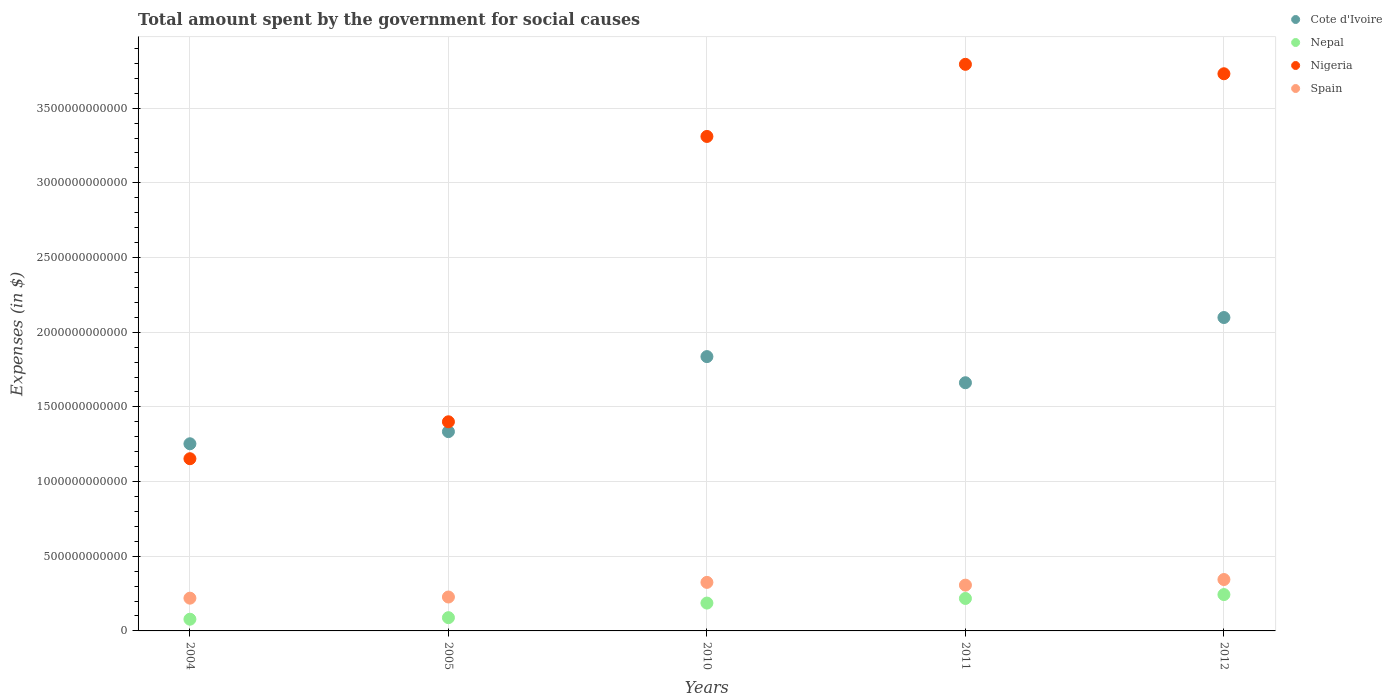What is the amount spent for social causes by the government in Nigeria in 2010?
Offer a terse response. 3.31e+12. Across all years, what is the maximum amount spent for social causes by the government in Cote d'Ivoire?
Offer a terse response. 2.10e+12. Across all years, what is the minimum amount spent for social causes by the government in Nepal?
Offer a very short reply. 7.83e+1. In which year was the amount spent for social causes by the government in Cote d'Ivoire minimum?
Provide a succinct answer. 2004. What is the total amount spent for social causes by the government in Nigeria in the graph?
Your answer should be compact. 1.34e+13. What is the difference between the amount spent for social causes by the government in Spain in 2004 and that in 2011?
Your answer should be compact. -8.73e+1. What is the difference between the amount spent for social causes by the government in Nepal in 2011 and the amount spent for social causes by the government in Nigeria in 2010?
Keep it short and to the point. -3.09e+12. What is the average amount spent for social causes by the government in Spain per year?
Offer a terse response. 2.84e+11. In the year 2004, what is the difference between the amount spent for social causes by the government in Cote d'Ivoire and amount spent for social causes by the government in Nepal?
Give a very brief answer. 1.17e+12. What is the ratio of the amount spent for social causes by the government in Spain in 2010 to that in 2011?
Offer a very short reply. 1.06. What is the difference between the highest and the second highest amount spent for social causes by the government in Nepal?
Make the answer very short. 2.60e+1. What is the difference between the highest and the lowest amount spent for social causes by the government in Nigeria?
Offer a very short reply. 2.64e+12. In how many years, is the amount spent for social causes by the government in Nepal greater than the average amount spent for social causes by the government in Nepal taken over all years?
Offer a terse response. 3. Is the sum of the amount spent for social causes by the government in Nigeria in 2010 and 2011 greater than the maximum amount spent for social causes by the government in Spain across all years?
Keep it short and to the point. Yes. Is the amount spent for social causes by the government in Nepal strictly greater than the amount spent for social causes by the government in Nigeria over the years?
Your answer should be very brief. No. What is the difference between two consecutive major ticks on the Y-axis?
Give a very brief answer. 5.00e+11. Where does the legend appear in the graph?
Offer a terse response. Top right. What is the title of the graph?
Keep it short and to the point. Total amount spent by the government for social causes. Does "St. Vincent and the Grenadines" appear as one of the legend labels in the graph?
Provide a short and direct response. No. What is the label or title of the X-axis?
Give a very brief answer. Years. What is the label or title of the Y-axis?
Your answer should be compact. Expenses (in $). What is the Expenses (in $) in Cote d'Ivoire in 2004?
Offer a very short reply. 1.25e+12. What is the Expenses (in $) of Nepal in 2004?
Your answer should be compact. 7.83e+1. What is the Expenses (in $) in Nigeria in 2004?
Offer a terse response. 1.15e+12. What is the Expenses (in $) of Spain in 2004?
Your answer should be compact. 2.19e+11. What is the Expenses (in $) of Cote d'Ivoire in 2005?
Your answer should be very brief. 1.33e+12. What is the Expenses (in $) in Nepal in 2005?
Make the answer very short. 8.88e+1. What is the Expenses (in $) in Nigeria in 2005?
Ensure brevity in your answer.  1.40e+12. What is the Expenses (in $) in Spain in 2005?
Ensure brevity in your answer.  2.27e+11. What is the Expenses (in $) in Cote d'Ivoire in 2010?
Ensure brevity in your answer.  1.84e+12. What is the Expenses (in $) of Nepal in 2010?
Your response must be concise. 1.86e+11. What is the Expenses (in $) in Nigeria in 2010?
Offer a very short reply. 3.31e+12. What is the Expenses (in $) of Spain in 2010?
Ensure brevity in your answer.  3.25e+11. What is the Expenses (in $) of Cote d'Ivoire in 2011?
Provide a succinct answer. 1.66e+12. What is the Expenses (in $) of Nepal in 2011?
Your answer should be compact. 2.17e+11. What is the Expenses (in $) of Nigeria in 2011?
Provide a short and direct response. 3.79e+12. What is the Expenses (in $) of Spain in 2011?
Offer a very short reply. 3.07e+11. What is the Expenses (in $) in Cote d'Ivoire in 2012?
Ensure brevity in your answer.  2.10e+12. What is the Expenses (in $) in Nepal in 2012?
Give a very brief answer. 2.43e+11. What is the Expenses (in $) of Nigeria in 2012?
Give a very brief answer. 3.73e+12. What is the Expenses (in $) of Spain in 2012?
Offer a very short reply. 3.44e+11. Across all years, what is the maximum Expenses (in $) of Cote d'Ivoire?
Give a very brief answer. 2.10e+12. Across all years, what is the maximum Expenses (in $) in Nepal?
Provide a succinct answer. 2.43e+11. Across all years, what is the maximum Expenses (in $) in Nigeria?
Your answer should be compact. 3.79e+12. Across all years, what is the maximum Expenses (in $) in Spain?
Provide a short and direct response. 3.44e+11. Across all years, what is the minimum Expenses (in $) in Cote d'Ivoire?
Provide a short and direct response. 1.25e+12. Across all years, what is the minimum Expenses (in $) in Nepal?
Ensure brevity in your answer.  7.83e+1. Across all years, what is the minimum Expenses (in $) of Nigeria?
Offer a very short reply. 1.15e+12. Across all years, what is the minimum Expenses (in $) in Spain?
Keep it short and to the point. 2.19e+11. What is the total Expenses (in $) of Cote d'Ivoire in the graph?
Offer a terse response. 8.18e+12. What is the total Expenses (in $) of Nepal in the graph?
Offer a very short reply. 8.14e+11. What is the total Expenses (in $) of Nigeria in the graph?
Provide a succinct answer. 1.34e+13. What is the total Expenses (in $) of Spain in the graph?
Provide a short and direct response. 1.42e+12. What is the difference between the Expenses (in $) of Cote d'Ivoire in 2004 and that in 2005?
Your answer should be compact. -8.12e+1. What is the difference between the Expenses (in $) of Nepal in 2004 and that in 2005?
Make the answer very short. -1.04e+1. What is the difference between the Expenses (in $) of Nigeria in 2004 and that in 2005?
Your answer should be compact. -2.47e+11. What is the difference between the Expenses (in $) in Spain in 2004 and that in 2005?
Provide a succinct answer. -7.71e+09. What is the difference between the Expenses (in $) of Cote d'Ivoire in 2004 and that in 2010?
Your answer should be compact. -5.84e+11. What is the difference between the Expenses (in $) of Nepal in 2004 and that in 2010?
Provide a short and direct response. -1.08e+11. What is the difference between the Expenses (in $) of Nigeria in 2004 and that in 2010?
Your answer should be compact. -2.16e+12. What is the difference between the Expenses (in $) in Spain in 2004 and that in 2010?
Make the answer very short. -1.06e+11. What is the difference between the Expenses (in $) of Cote d'Ivoire in 2004 and that in 2011?
Your response must be concise. -4.09e+11. What is the difference between the Expenses (in $) of Nepal in 2004 and that in 2011?
Provide a short and direct response. -1.39e+11. What is the difference between the Expenses (in $) in Nigeria in 2004 and that in 2011?
Provide a succinct answer. -2.64e+12. What is the difference between the Expenses (in $) of Spain in 2004 and that in 2011?
Offer a terse response. -8.73e+1. What is the difference between the Expenses (in $) of Cote d'Ivoire in 2004 and that in 2012?
Give a very brief answer. -8.45e+11. What is the difference between the Expenses (in $) in Nepal in 2004 and that in 2012?
Give a very brief answer. -1.65e+11. What is the difference between the Expenses (in $) of Nigeria in 2004 and that in 2012?
Offer a very short reply. -2.58e+12. What is the difference between the Expenses (in $) in Spain in 2004 and that in 2012?
Offer a terse response. -1.25e+11. What is the difference between the Expenses (in $) of Cote d'Ivoire in 2005 and that in 2010?
Your response must be concise. -5.02e+11. What is the difference between the Expenses (in $) of Nepal in 2005 and that in 2010?
Provide a succinct answer. -9.77e+1. What is the difference between the Expenses (in $) in Nigeria in 2005 and that in 2010?
Your answer should be very brief. -1.91e+12. What is the difference between the Expenses (in $) in Spain in 2005 and that in 2010?
Your answer should be very brief. -9.80e+1. What is the difference between the Expenses (in $) in Cote d'Ivoire in 2005 and that in 2011?
Give a very brief answer. -3.27e+11. What is the difference between the Expenses (in $) in Nepal in 2005 and that in 2011?
Your response must be concise. -1.29e+11. What is the difference between the Expenses (in $) of Nigeria in 2005 and that in 2011?
Provide a succinct answer. -2.39e+12. What is the difference between the Expenses (in $) of Spain in 2005 and that in 2011?
Give a very brief answer. -7.96e+1. What is the difference between the Expenses (in $) of Cote d'Ivoire in 2005 and that in 2012?
Make the answer very short. -7.64e+11. What is the difference between the Expenses (in $) in Nepal in 2005 and that in 2012?
Offer a very short reply. -1.55e+11. What is the difference between the Expenses (in $) of Nigeria in 2005 and that in 2012?
Give a very brief answer. -2.33e+12. What is the difference between the Expenses (in $) in Spain in 2005 and that in 2012?
Your response must be concise. -1.17e+11. What is the difference between the Expenses (in $) of Cote d'Ivoire in 2010 and that in 2011?
Ensure brevity in your answer.  1.75e+11. What is the difference between the Expenses (in $) in Nepal in 2010 and that in 2011?
Your response must be concise. -3.08e+1. What is the difference between the Expenses (in $) of Nigeria in 2010 and that in 2011?
Provide a short and direct response. -4.83e+11. What is the difference between the Expenses (in $) in Spain in 2010 and that in 2011?
Provide a short and direct response. 1.84e+1. What is the difference between the Expenses (in $) in Cote d'Ivoire in 2010 and that in 2012?
Keep it short and to the point. -2.62e+11. What is the difference between the Expenses (in $) of Nepal in 2010 and that in 2012?
Give a very brief answer. -5.69e+1. What is the difference between the Expenses (in $) in Nigeria in 2010 and that in 2012?
Your answer should be compact. -4.20e+11. What is the difference between the Expenses (in $) in Spain in 2010 and that in 2012?
Keep it short and to the point. -1.91e+1. What is the difference between the Expenses (in $) of Cote d'Ivoire in 2011 and that in 2012?
Your answer should be very brief. -4.37e+11. What is the difference between the Expenses (in $) in Nepal in 2011 and that in 2012?
Your response must be concise. -2.60e+1. What is the difference between the Expenses (in $) of Nigeria in 2011 and that in 2012?
Keep it short and to the point. 6.32e+1. What is the difference between the Expenses (in $) of Spain in 2011 and that in 2012?
Keep it short and to the point. -3.75e+1. What is the difference between the Expenses (in $) in Cote d'Ivoire in 2004 and the Expenses (in $) in Nepal in 2005?
Your answer should be very brief. 1.16e+12. What is the difference between the Expenses (in $) in Cote d'Ivoire in 2004 and the Expenses (in $) in Nigeria in 2005?
Make the answer very short. -1.47e+11. What is the difference between the Expenses (in $) of Cote d'Ivoire in 2004 and the Expenses (in $) of Spain in 2005?
Your response must be concise. 1.03e+12. What is the difference between the Expenses (in $) of Nepal in 2004 and the Expenses (in $) of Nigeria in 2005?
Ensure brevity in your answer.  -1.32e+12. What is the difference between the Expenses (in $) of Nepal in 2004 and the Expenses (in $) of Spain in 2005?
Provide a succinct answer. -1.49e+11. What is the difference between the Expenses (in $) of Nigeria in 2004 and the Expenses (in $) of Spain in 2005?
Your answer should be very brief. 9.26e+11. What is the difference between the Expenses (in $) in Cote d'Ivoire in 2004 and the Expenses (in $) in Nepal in 2010?
Your response must be concise. 1.07e+12. What is the difference between the Expenses (in $) of Cote d'Ivoire in 2004 and the Expenses (in $) of Nigeria in 2010?
Offer a very short reply. -2.06e+12. What is the difference between the Expenses (in $) of Cote d'Ivoire in 2004 and the Expenses (in $) of Spain in 2010?
Provide a short and direct response. 9.28e+11. What is the difference between the Expenses (in $) of Nepal in 2004 and the Expenses (in $) of Nigeria in 2010?
Your response must be concise. -3.23e+12. What is the difference between the Expenses (in $) in Nepal in 2004 and the Expenses (in $) in Spain in 2010?
Ensure brevity in your answer.  -2.47e+11. What is the difference between the Expenses (in $) in Nigeria in 2004 and the Expenses (in $) in Spain in 2010?
Give a very brief answer. 8.28e+11. What is the difference between the Expenses (in $) in Cote d'Ivoire in 2004 and the Expenses (in $) in Nepal in 2011?
Your answer should be very brief. 1.04e+12. What is the difference between the Expenses (in $) in Cote d'Ivoire in 2004 and the Expenses (in $) in Nigeria in 2011?
Your answer should be compact. -2.54e+12. What is the difference between the Expenses (in $) of Cote d'Ivoire in 2004 and the Expenses (in $) of Spain in 2011?
Your answer should be compact. 9.47e+11. What is the difference between the Expenses (in $) of Nepal in 2004 and the Expenses (in $) of Nigeria in 2011?
Make the answer very short. -3.72e+12. What is the difference between the Expenses (in $) in Nepal in 2004 and the Expenses (in $) in Spain in 2011?
Your response must be concise. -2.28e+11. What is the difference between the Expenses (in $) of Nigeria in 2004 and the Expenses (in $) of Spain in 2011?
Offer a terse response. 8.46e+11. What is the difference between the Expenses (in $) of Cote d'Ivoire in 2004 and the Expenses (in $) of Nepal in 2012?
Offer a terse response. 1.01e+12. What is the difference between the Expenses (in $) of Cote d'Ivoire in 2004 and the Expenses (in $) of Nigeria in 2012?
Your answer should be very brief. -2.48e+12. What is the difference between the Expenses (in $) of Cote d'Ivoire in 2004 and the Expenses (in $) of Spain in 2012?
Give a very brief answer. 9.09e+11. What is the difference between the Expenses (in $) of Nepal in 2004 and the Expenses (in $) of Nigeria in 2012?
Make the answer very short. -3.65e+12. What is the difference between the Expenses (in $) of Nepal in 2004 and the Expenses (in $) of Spain in 2012?
Offer a very short reply. -2.66e+11. What is the difference between the Expenses (in $) in Nigeria in 2004 and the Expenses (in $) in Spain in 2012?
Make the answer very short. 8.09e+11. What is the difference between the Expenses (in $) of Cote d'Ivoire in 2005 and the Expenses (in $) of Nepal in 2010?
Make the answer very short. 1.15e+12. What is the difference between the Expenses (in $) in Cote d'Ivoire in 2005 and the Expenses (in $) in Nigeria in 2010?
Make the answer very short. -1.98e+12. What is the difference between the Expenses (in $) in Cote d'Ivoire in 2005 and the Expenses (in $) in Spain in 2010?
Provide a short and direct response. 1.01e+12. What is the difference between the Expenses (in $) of Nepal in 2005 and the Expenses (in $) of Nigeria in 2010?
Offer a terse response. -3.22e+12. What is the difference between the Expenses (in $) of Nepal in 2005 and the Expenses (in $) of Spain in 2010?
Provide a succinct answer. -2.36e+11. What is the difference between the Expenses (in $) of Nigeria in 2005 and the Expenses (in $) of Spain in 2010?
Make the answer very short. 1.08e+12. What is the difference between the Expenses (in $) of Cote d'Ivoire in 2005 and the Expenses (in $) of Nepal in 2011?
Your answer should be very brief. 1.12e+12. What is the difference between the Expenses (in $) of Cote d'Ivoire in 2005 and the Expenses (in $) of Nigeria in 2011?
Give a very brief answer. -2.46e+12. What is the difference between the Expenses (in $) in Cote d'Ivoire in 2005 and the Expenses (in $) in Spain in 2011?
Your response must be concise. 1.03e+12. What is the difference between the Expenses (in $) in Nepal in 2005 and the Expenses (in $) in Nigeria in 2011?
Make the answer very short. -3.70e+12. What is the difference between the Expenses (in $) in Nepal in 2005 and the Expenses (in $) in Spain in 2011?
Provide a short and direct response. -2.18e+11. What is the difference between the Expenses (in $) of Nigeria in 2005 and the Expenses (in $) of Spain in 2011?
Keep it short and to the point. 1.09e+12. What is the difference between the Expenses (in $) in Cote d'Ivoire in 2005 and the Expenses (in $) in Nepal in 2012?
Offer a very short reply. 1.09e+12. What is the difference between the Expenses (in $) of Cote d'Ivoire in 2005 and the Expenses (in $) of Nigeria in 2012?
Give a very brief answer. -2.40e+12. What is the difference between the Expenses (in $) of Cote d'Ivoire in 2005 and the Expenses (in $) of Spain in 2012?
Give a very brief answer. 9.90e+11. What is the difference between the Expenses (in $) of Nepal in 2005 and the Expenses (in $) of Nigeria in 2012?
Offer a terse response. -3.64e+12. What is the difference between the Expenses (in $) in Nepal in 2005 and the Expenses (in $) in Spain in 2012?
Make the answer very short. -2.55e+11. What is the difference between the Expenses (in $) in Nigeria in 2005 and the Expenses (in $) in Spain in 2012?
Provide a succinct answer. 1.06e+12. What is the difference between the Expenses (in $) of Cote d'Ivoire in 2010 and the Expenses (in $) of Nepal in 2011?
Give a very brief answer. 1.62e+12. What is the difference between the Expenses (in $) of Cote d'Ivoire in 2010 and the Expenses (in $) of Nigeria in 2011?
Give a very brief answer. -1.96e+12. What is the difference between the Expenses (in $) of Cote d'Ivoire in 2010 and the Expenses (in $) of Spain in 2011?
Give a very brief answer. 1.53e+12. What is the difference between the Expenses (in $) in Nepal in 2010 and the Expenses (in $) in Nigeria in 2011?
Offer a very short reply. -3.61e+12. What is the difference between the Expenses (in $) in Nepal in 2010 and the Expenses (in $) in Spain in 2011?
Ensure brevity in your answer.  -1.20e+11. What is the difference between the Expenses (in $) of Nigeria in 2010 and the Expenses (in $) of Spain in 2011?
Your answer should be very brief. 3.00e+12. What is the difference between the Expenses (in $) of Cote d'Ivoire in 2010 and the Expenses (in $) of Nepal in 2012?
Make the answer very short. 1.59e+12. What is the difference between the Expenses (in $) of Cote d'Ivoire in 2010 and the Expenses (in $) of Nigeria in 2012?
Ensure brevity in your answer.  -1.89e+12. What is the difference between the Expenses (in $) of Cote d'Ivoire in 2010 and the Expenses (in $) of Spain in 2012?
Your answer should be compact. 1.49e+12. What is the difference between the Expenses (in $) in Nepal in 2010 and the Expenses (in $) in Nigeria in 2012?
Offer a terse response. -3.54e+12. What is the difference between the Expenses (in $) of Nepal in 2010 and the Expenses (in $) of Spain in 2012?
Provide a short and direct response. -1.58e+11. What is the difference between the Expenses (in $) in Nigeria in 2010 and the Expenses (in $) in Spain in 2012?
Give a very brief answer. 2.97e+12. What is the difference between the Expenses (in $) in Cote d'Ivoire in 2011 and the Expenses (in $) in Nepal in 2012?
Provide a succinct answer. 1.42e+12. What is the difference between the Expenses (in $) of Cote d'Ivoire in 2011 and the Expenses (in $) of Nigeria in 2012?
Keep it short and to the point. -2.07e+12. What is the difference between the Expenses (in $) in Cote d'Ivoire in 2011 and the Expenses (in $) in Spain in 2012?
Keep it short and to the point. 1.32e+12. What is the difference between the Expenses (in $) of Nepal in 2011 and the Expenses (in $) of Nigeria in 2012?
Your response must be concise. -3.51e+12. What is the difference between the Expenses (in $) of Nepal in 2011 and the Expenses (in $) of Spain in 2012?
Offer a very short reply. -1.27e+11. What is the difference between the Expenses (in $) in Nigeria in 2011 and the Expenses (in $) in Spain in 2012?
Your answer should be compact. 3.45e+12. What is the average Expenses (in $) in Cote d'Ivoire per year?
Your answer should be compact. 1.64e+12. What is the average Expenses (in $) of Nepal per year?
Give a very brief answer. 1.63e+11. What is the average Expenses (in $) of Nigeria per year?
Offer a terse response. 2.68e+12. What is the average Expenses (in $) of Spain per year?
Make the answer very short. 2.84e+11. In the year 2004, what is the difference between the Expenses (in $) of Cote d'Ivoire and Expenses (in $) of Nepal?
Offer a very short reply. 1.17e+12. In the year 2004, what is the difference between the Expenses (in $) of Cote d'Ivoire and Expenses (in $) of Nigeria?
Ensure brevity in your answer.  1.00e+11. In the year 2004, what is the difference between the Expenses (in $) in Cote d'Ivoire and Expenses (in $) in Spain?
Offer a terse response. 1.03e+12. In the year 2004, what is the difference between the Expenses (in $) in Nepal and Expenses (in $) in Nigeria?
Ensure brevity in your answer.  -1.07e+12. In the year 2004, what is the difference between the Expenses (in $) of Nepal and Expenses (in $) of Spain?
Your answer should be very brief. -1.41e+11. In the year 2004, what is the difference between the Expenses (in $) of Nigeria and Expenses (in $) of Spain?
Your answer should be very brief. 9.34e+11. In the year 2005, what is the difference between the Expenses (in $) in Cote d'Ivoire and Expenses (in $) in Nepal?
Your answer should be very brief. 1.25e+12. In the year 2005, what is the difference between the Expenses (in $) of Cote d'Ivoire and Expenses (in $) of Nigeria?
Ensure brevity in your answer.  -6.60e+1. In the year 2005, what is the difference between the Expenses (in $) of Cote d'Ivoire and Expenses (in $) of Spain?
Ensure brevity in your answer.  1.11e+12. In the year 2005, what is the difference between the Expenses (in $) of Nepal and Expenses (in $) of Nigeria?
Provide a succinct answer. -1.31e+12. In the year 2005, what is the difference between the Expenses (in $) in Nepal and Expenses (in $) in Spain?
Provide a short and direct response. -1.38e+11. In the year 2005, what is the difference between the Expenses (in $) in Nigeria and Expenses (in $) in Spain?
Your answer should be compact. 1.17e+12. In the year 2010, what is the difference between the Expenses (in $) of Cote d'Ivoire and Expenses (in $) of Nepal?
Make the answer very short. 1.65e+12. In the year 2010, what is the difference between the Expenses (in $) in Cote d'Ivoire and Expenses (in $) in Nigeria?
Give a very brief answer. -1.47e+12. In the year 2010, what is the difference between the Expenses (in $) in Cote d'Ivoire and Expenses (in $) in Spain?
Make the answer very short. 1.51e+12. In the year 2010, what is the difference between the Expenses (in $) in Nepal and Expenses (in $) in Nigeria?
Ensure brevity in your answer.  -3.12e+12. In the year 2010, what is the difference between the Expenses (in $) of Nepal and Expenses (in $) of Spain?
Give a very brief answer. -1.39e+11. In the year 2010, what is the difference between the Expenses (in $) in Nigeria and Expenses (in $) in Spain?
Offer a very short reply. 2.99e+12. In the year 2011, what is the difference between the Expenses (in $) in Cote d'Ivoire and Expenses (in $) in Nepal?
Provide a short and direct response. 1.44e+12. In the year 2011, what is the difference between the Expenses (in $) in Cote d'Ivoire and Expenses (in $) in Nigeria?
Keep it short and to the point. -2.13e+12. In the year 2011, what is the difference between the Expenses (in $) of Cote d'Ivoire and Expenses (in $) of Spain?
Offer a terse response. 1.36e+12. In the year 2011, what is the difference between the Expenses (in $) in Nepal and Expenses (in $) in Nigeria?
Offer a very short reply. -3.58e+12. In the year 2011, what is the difference between the Expenses (in $) in Nepal and Expenses (in $) in Spain?
Ensure brevity in your answer.  -8.93e+1. In the year 2011, what is the difference between the Expenses (in $) in Nigeria and Expenses (in $) in Spain?
Offer a very short reply. 3.49e+12. In the year 2012, what is the difference between the Expenses (in $) of Cote d'Ivoire and Expenses (in $) of Nepal?
Offer a terse response. 1.86e+12. In the year 2012, what is the difference between the Expenses (in $) of Cote d'Ivoire and Expenses (in $) of Nigeria?
Your answer should be compact. -1.63e+12. In the year 2012, what is the difference between the Expenses (in $) of Cote d'Ivoire and Expenses (in $) of Spain?
Make the answer very short. 1.75e+12. In the year 2012, what is the difference between the Expenses (in $) of Nepal and Expenses (in $) of Nigeria?
Your answer should be very brief. -3.49e+12. In the year 2012, what is the difference between the Expenses (in $) of Nepal and Expenses (in $) of Spain?
Your answer should be very brief. -1.01e+11. In the year 2012, what is the difference between the Expenses (in $) in Nigeria and Expenses (in $) in Spain?
Offer a very short reply. 3.39e+12. What is the ratio of the Expenses (in $) in Cote d'Ivoire in 2004 to that in 2005?
Provide a succinct answer. 0.94. What is the ratio of the Expenses (in $) of Nepal in 2004 to that in 2005?
Your answer should be compact. 0.88. What is the ratio of the Expenses (in $) in Nigeria in 2004 to that in 2005?
Your answer should be compact. 0.82. What is the ratio of the Expenses (in $) in Spain in 2004 to that in 2005?
Keep it short and to the point. 0.97. What is the ratio of the Expenses (in $) of Cote d'Ivoire in 2004 to that in 2010?
Your answer should be compact. 0.68. What is the ratio of the Expenses (in $) in Nepal in 2004 to that in 2010?
Keep it short and to the point. 0.42. What is the ratio of the Expenses (in $) of Nigeria in 2004 to that in 2010?
Offer a terse response. 0.35. What is the ratio of the Expenses (in $) in Spain in 2004 to that in 2010?
Your response must be concise. 0.67. What is the ratio of the Expenses (in $) of Cote d'Ivoire in 2004 to that in 2011?
Your response must be concise. 0.75. What is the ratio of the Expenses (in $) in Nepal in 2004 to that in 2011?
Keep it short and to the point. 0.36. What is the ratio of the Expenses (in $) in Nigeria in 2004 to that in 2011?
Give a very brief answer. 0.3. What is the ratio of the Expenses (in $) in Spain in 2004 to that in 2011?
Keep it short and to the point. 0.72. What is the ratio of the Expenses (in $) in Cote d'Ivoire in 2004 to that in 2012?
Your answer should be very brief. 0.6. What is the ratio of the Expenses (in $) in Nepal in 2004 to that in 2012?
Your answer should be very brief. 0.32. What is the ratio of the Expenses (in $) of Nigeria in 2004 to that in 2012?
Provide a succinct answer. 0.31. What is the ratio of the Expenses (in $) of Spain in 2004 to that in 2012?
Provide a succinct answer. 0.64. What is the ratio of the Expenses (in $) in Cote d'Ivoire in 2005 to that in 2010?
Give a very brief answer. 0.73. What is the ratio of the Expenses (in $) of Nepal in 2005 to that in 2010?
Provide a succinct answer. 0.48. What is the ratio of the Expenses (in $) of Nigeria in 2005 to that in 2010?
Give a very brief answer. 0.42. What is the ratio of the Expenses (in $) in Spain in 2005 to that in 2010?
Offer a terse response. 0.7. What is the ratio of the Expenses (in $) of Cote d'Ivoire in 2005 to that in 2011?
Offer a very short reply. 0.8. What is the ratio of the Expenses (in $) in Nepal in 2005 to that in 2011?
Your response must be concise. 0.41. What is the ratio of the Expenses (in $) of Nigeria in 2005 to that in 2011?
Offer a very short reply. 0.37. What is the ratio of the Expenses (in $) in Spain in 2005 to that in 2011?
Your response must be concise. 0.74. What is the ratio of the Expenses (in $) in Cote d'Ivoire in 2005 to that in 2012?
Offer a terse response. 0.64. What is the ratio of the Expenses (in $) of Nepal in 2005 to that in 2012?
Offer a terse response. 0.36. What is the ratio of the Expenses (in $) of Nigeria in 2005 to that in 2012?
Keep it short and to the point. 0.38. What is the ratio of the Expenses (in $) in Spain in 2005 to that in 2012?
Give a very brief answer. 0.66. What is the ratio of the Expenses (in $) of Cote d'Ivoire in 2010 to that in 2011?
Provide a short and direct response. 1.11. What is the ratio of the Expenses (in $) in Nepal in 2010 to that in 2011?
Make the answer very short. 0.86. What is the ratio of the Expenses (in $) of Nigeria in 2010 to that in 2011?
Ensure brevity in your answer.  0.87. What is the ratio of the Expenses (in $) in Spain in 2010 to that in 2011?
Make the answer very short. 1.06. What is the ratio of the Expenses (in $) in Cote d'Ivoire in 2010 to that in 2012?
Ensure brevity in your answer.  0.88. What is the ratio of the Expenses (in $) of Nepal in 2010 to that in 2012?
Make the answer very short. 0.77. What is the ratio of the Expenses (in $) of Nigeria in 2010 to that in 2012?
Keep it short and to the point. 0.89. What is the ratio of the Expenses (in $) of Spain in 2010 to that in 2012?
Your answer should be very brief. 0.94. What is the ratio of the Expenses (in $) of Cote d'Ivoire in 2011 to that in 2012?
Your answer should be compact. 0.79. What is the ratio of the Expenses (in $) of Nepal in 2011 to that in 2012?
Provide a short and direct response. 0.89. What is the ratio of the Expenses (in $) of Nigeria in 2011 to that in 2012?
Keep it short and to the point. 1.02. What is the ratio of the Expenses (in $) in Spain in 2011 to that in 2012?
Your answer should be compact. 0.89. What is the difference between the highest and the second highest Expenses (in $) of Cote d'Ivoire?
Your answer should be compact. 2.62e+11. What is the difference between the highest and the second highest Expenses (in $) in Nepal?
Make the answer very short. 2.60e+1. What is the difference between the highest and the second highest Expenses (in $) in Nigeria?
Offer a terse response. 6.32e+1. What is the difference between the highest and the second highest Expenses (in $) of Spain?
Offer a terse response. 1.91e+1. What is the difference between the highest and the lowest Expenses (in $) in Cote d'Ivoire?
Provide a succinct answer. 8.45e+11. What is the difference between the highest and the lowest Expenses (in $) of Nepal?
Provide a succinct answer. 1.65e+11. What is the difference between the highest and the lowest Expenses (in $) in Nigeria?
Your answer should be compact. 2.64e+12. What is the difference between the highest and the lowest Expenses (in $) of Spain?
Your answer should be very brief. 1.25e+11. 